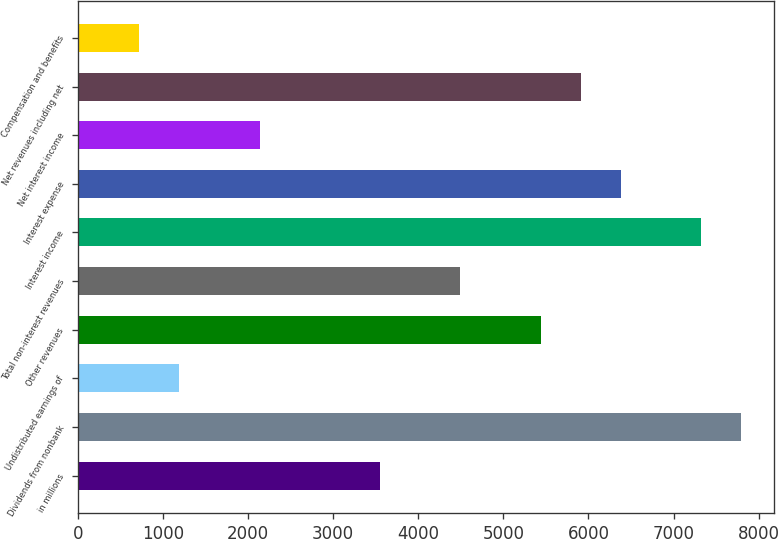Convert chart. <chart><loc_0><loc_0><loc_500><loc_500><bar_chart><fcel>in millions<fcel>Dividends from nonbank<fcel>Undistributed earnings of<fcel>Other revenues<fcel>Total non-interest revenues<fcel>Interest income<fcel>Interest expense<fcel>Net interest income<fcel>Net revenues including net<fcel>Compensation and benefits<nl><fcel>3552.5<fcel>7796<fcel>1195<fcel>5438.5<fcel>4495.5<fcel>7324.5<fcel>6381.5<fcel>2138<fcel>5910<fcel>723.5<nl></chart> 